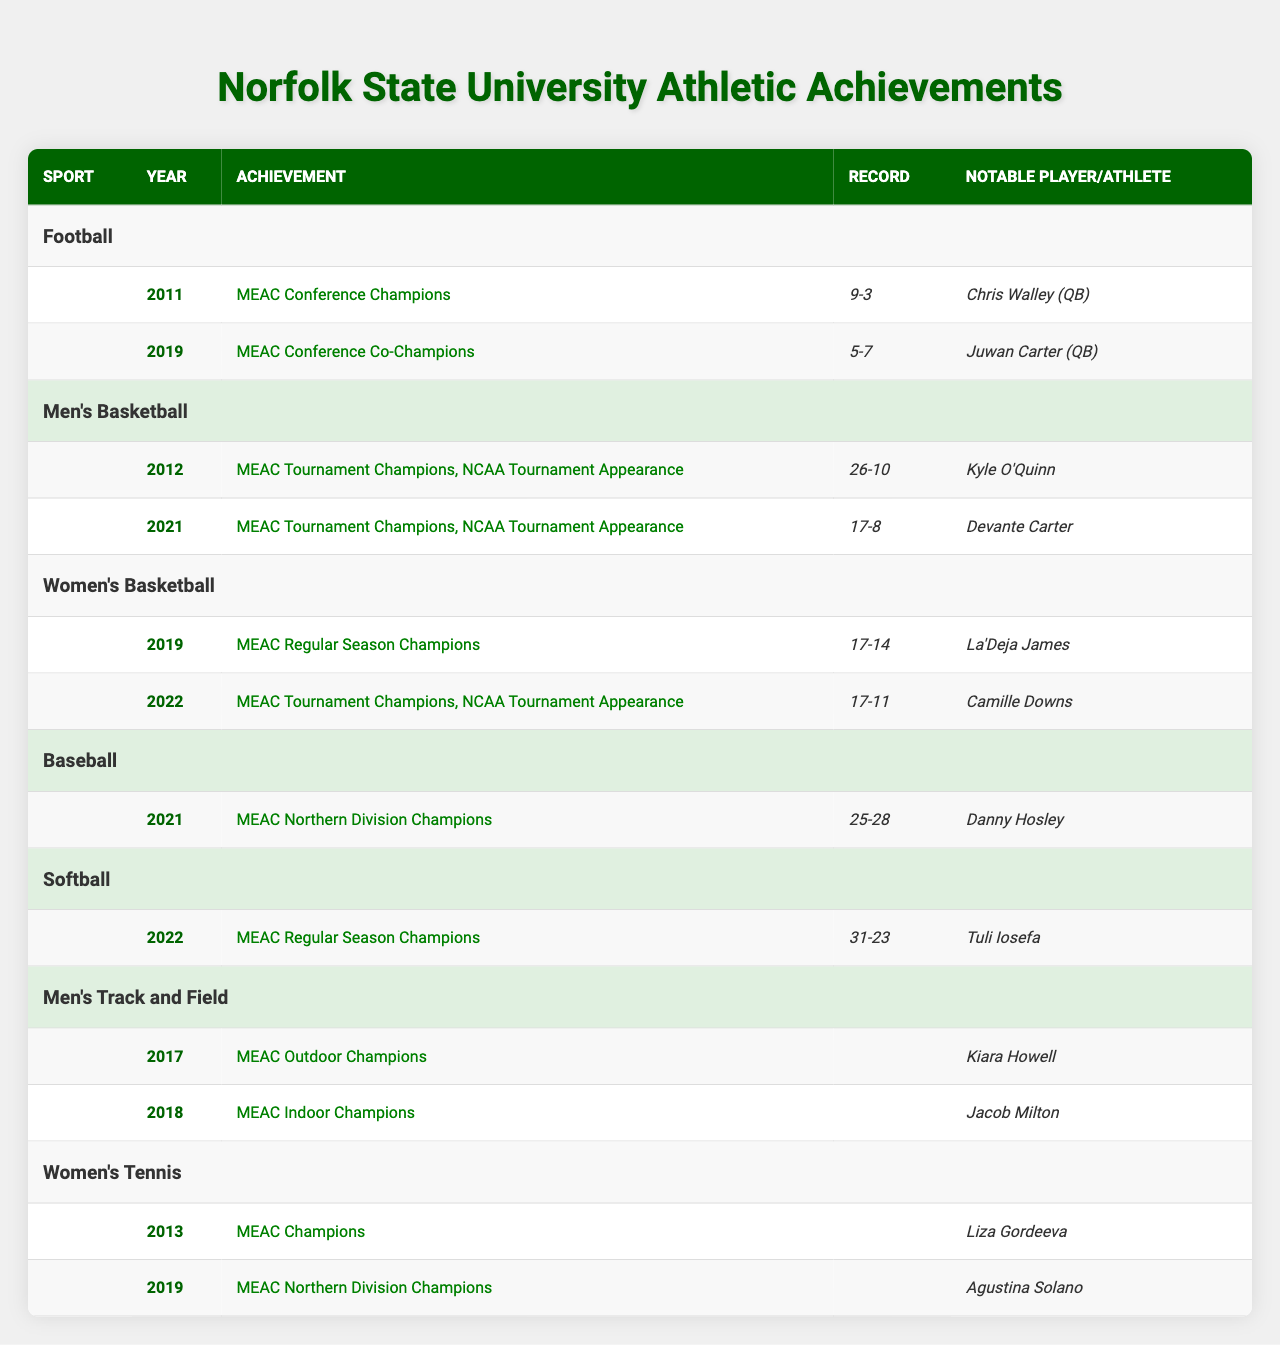What year did the Norfolk State football team become MEAC Conference Champions? The table shows that the Norfolk State football team achieved this title in 2011.
Answer: 2011 Which sport's team had a notable player named Camille Downs? The table indicates that Camille Downs was the notable player for the Women's Basketball team in the year 2022.
Answer: Women's Basketball Was there a year when both the Men's and Women's Basketball teams won MEAC Tournament Championships? Yes, both the Men's Basketball team in 2012 and the Women's Basketball team in 2021 achieved this accomplishment.
Answer: Yes In which year did the Men's Track and Field team win the MEAC Indoor Championships? According to the table, the Men's Track and Field team won the MEAC Indoor Championships in 2018.
Answer: 2018 Which team had a losing record while being MEAC Conference Co-Champions? The Norfolk State football team had a record of 5-7 while being MEAC Conference Co-Champions in 2019.
Answer: Football What is the record for the Women's Basketball team in the year they became MEAC Regular Season Champions? The Women's Basketball team had a record of 17-14 during their MEAC Regular Season Championship in 2019.
Answer: 17-14 Which sport had the most recent championship victory listed in the table? The Softball team became MEAC Regular Season Champions in 2022, which is the most recent championship noted.
Answer: Softball How many different sports have achieved championships in the table? The table lists championships achieved in six different sports: Football, Men's Basketball, Women's Basketball, Baseball, Softball, Men's Track and Field, and Women's Tennis.
Answer: Six Did any Norfolk State sport win a conference championship in 2021? Yes, the Baseball team won the MEAC Northern Division Championship in 2021, but the football team had a losing record that year, not winning a championship.
Answer: Yes Which sport had a notable player named Juwan Carter? Juwan Carter was the notable player for the Norfolk State football team in 2019.
Answer: Football What is the total number of championships won by the Men's Basketball team as shown in this table? The Men's Basketball team won MEAC Tournament Championships in both 2012 and 2021, totaling two championships.
Answer: Two 